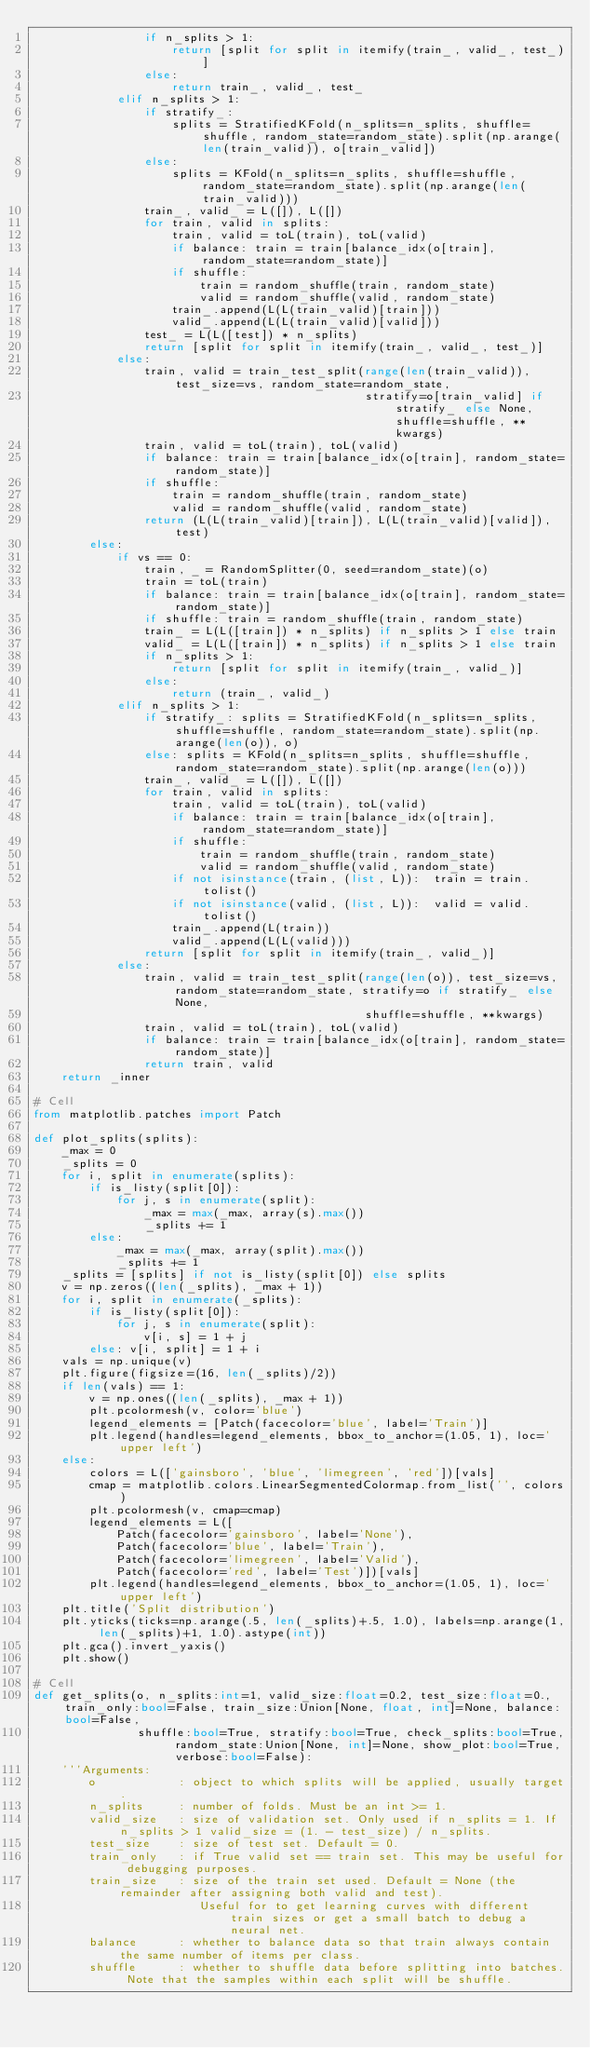<code> <loc_0><loc_0><loc_500><loc_500><_Python_>                if n_splits > 1:
                    return [split for split in itemify(train_, valid_, test_)]
                else:
                    return train_, valid_, test_
            elif n_splits > 1:
                if stratify_:
                    splits = StratifiedKFold(n_splits=n_splits, shuffle=shuffle, random_state=random_state).split(np.arange(len(train_valid)), o[train_valid])
                else:
                    splits = KFold(n_splits=n_splits, shuffle=shuffle, random_state=random_state).split(np.arange(len(train_valid)))
                train_, valid_ = L([]), L([])
                for train, valid in splits:
                    train, valid = toL(train), toL(valid)
                    if balance: train = train[balance_idx(o[train], random_state=random_state)]
                    if shuffle:
                        train = random_shuffle(train, random_state)
                        valid = random_shuffle(valid, random_state)
                    train_.append(L(L(train_valid)[train]))
                    valid_.append(L(L(train_valid)[valid]))
                test_ = L(L([test]) * n_splits)
                return [split for split in itemify(train_, valid_, test_)]
            else:
                train, valid = train_test_split(range(len(train_valid)), test_size=vs, random_state=random_state,
                                                stratify=o[train_valid] if stratify_ else None, shuffle=shuffle, **kwargs)
                train, valid = toL(train), toL(valid)
                if balance: train = train[balance_idx(o[train], random_state=random_state)]
                if shuffle:
                    train = random_shuffle(train, random_state)
                    valid = random_shuffle(valid, random_state)
                return (L(L(train_valid)[train]), L(L(train_valid)[valid]),  test)
        else:
            if vs == 0:
                train, _ = RandomSplitter(0, seed=random_state)(o)
                train = toL(train)
                if balance: train = train[balance_idx(o[train], random_state=random_state)]
                if shuffle: train = random_shuffle(train, random_state)
                train_ = L(L([train]) * n_splits) if n_splits > 1 else train
                valid_ = L(L([train]) * n_splits) if n_splits > 1 else train
                if n_splits > 1:
                    return [split for split in itemify(train_, valid_)]
                else:
                    return (train_, valid_)
            elif n_splits > 1:
                if stratify_: splits = StratifiedKFold(n_splits=n_splits, shuffle=shuffle, random_state=random_state).split(np.arange(len(o)), o)
                else: splits = KFold(n_splits=n_splits, shuffle=shuffle, random_state=random_state).split(np.arange(len(o)))
                train_, valid_ = L([]), L([])
                for train, valid in splits:
                    train, valid = toL(train), toL(valid)
                    if balance: train = train[balance_idx(o[train], random_state=random_state)]
                    if shuffle:
                        train = random_shuffle(train, random_state)
                        valid = random_shuffle(valid, random_state)
                    if not isinstance(train, (list, L)):  train = train.tolist()
                    if not isinstance(valid, (list, L)):  valid = valid.tolist()
                    train_.append(L(train))
                    valid_.append(L(L(valid)))
                return [split for split in itemify(train_, valid_)]
            else:
                train, valid = train_test_split(range(len(o)), test_size=vs, random_state=random_state, stratify=o if stratify_ else None,
                                                shuffle=shuffle, **kwargs)
                train, valid = toL(train), toL(valid)
                if balance: train = train[balance_idx(o[train], random_state=random_state)]
                return train, valid
    return _inner

# Cell
from matplotlib.patches import Patch

def plot_splits(splits):
    _max = 0
    _splits = 0
    for i, split in enumerate(splits):
        if is_listy(split[0]):
            for j, s in enumerate(split):
                _max = max(_max, array(s).max())
                _splits += 1
        else:
            _max = max(_max, array(split).max())
            _splits += 1
    _splits = [splits] if not is_listy(split[0]) else splits
    v = np.zeros((len(_splits), _max + 1))
    for i, split in enumerate(_splits):
        if is_listy(split[0]):
            for j, s in enumerate(split):
                v[i, s] = 1 + j
        else: v[i, split] = 1 + i
    vals = np.unique(v)
    plt.figure(figsize=(16, len(_splits)/2))
    if len(vals) == 1:
        v = np.ones((len(_splits), _max + 1))
        plt.pcolormesh(v, color='blue')
        legend_elements = [Patch(facecolor='blue', label='Train')]
        plt.legend(handles=legend_elements, bbox_to_anchor=(1.05, 1), loc='upper left')
    else:
        colors = L(['gainsboro', 'blue', 'limegreen', 'red'])[vals]
        cmap = matplotlib.colors.LinearSegmentedColormap.from_list('', colors)
        plt.pcolormesh(v, cmap=cmap)
        legend_elements = L([
            Patch(facecolor='gainsboro', label='None'),
            Patch(facecolor='blue', label='Train'),
            Patch(facecolor='limegreen', label='Valid'),
            Patch(facecolor='red', label='Test')])[vals]
        plt.legend(handles=legend_elements, bbox_to_anchor=(1.05, 1), loc='upper left')
    plt.title('Split distribution')
    plt.yticks(ticks=np.arange(.5, len(_splits)+.5, 1.0), labels=np.arange(1, len(_splits)+1, 1.0).astype(int))
    plt.gca().invert_yaxis()
    plt.show()

# Cell
def get_splits(o, n_splits:int=1, valid_size:float=0.2, test_size:float=0., train_only:bool=False, train_size:Union[None, float, int]=None, balance:bool=False,
               shuffle:bool=True, stratify:bool=True, check_splits:bool=True, random_state:Union[None, int]=None, show_plot:bool=True, verbose:bool=False):
    '''Arguments:
        o            : object to which splits will be applied, usually target.
        n_splits     : number of folds. Must be an int >= 1.
        valid_size   : size of validation set. Only used if n_splits = 1. If n_splits > 1 valid_size = (1. - test_size) / n_splits.
        test_size    : size of test set. Default = 0.
        train_only   : if True valid set == train set. This may be useful for debugging purposes.
        train_size   : size of the train set used. Default = None (the remainder after assigning both valid and test).
                        Useful for to get learning curves with different train sizes or get a small batch to debug a neural net.
        balance      : whether to balance data so that train always contain the same number of items per class.
        shuffle      : whether to shuffle data before splitting into batches. Note that the samples within each split will be shuffle.</code> 